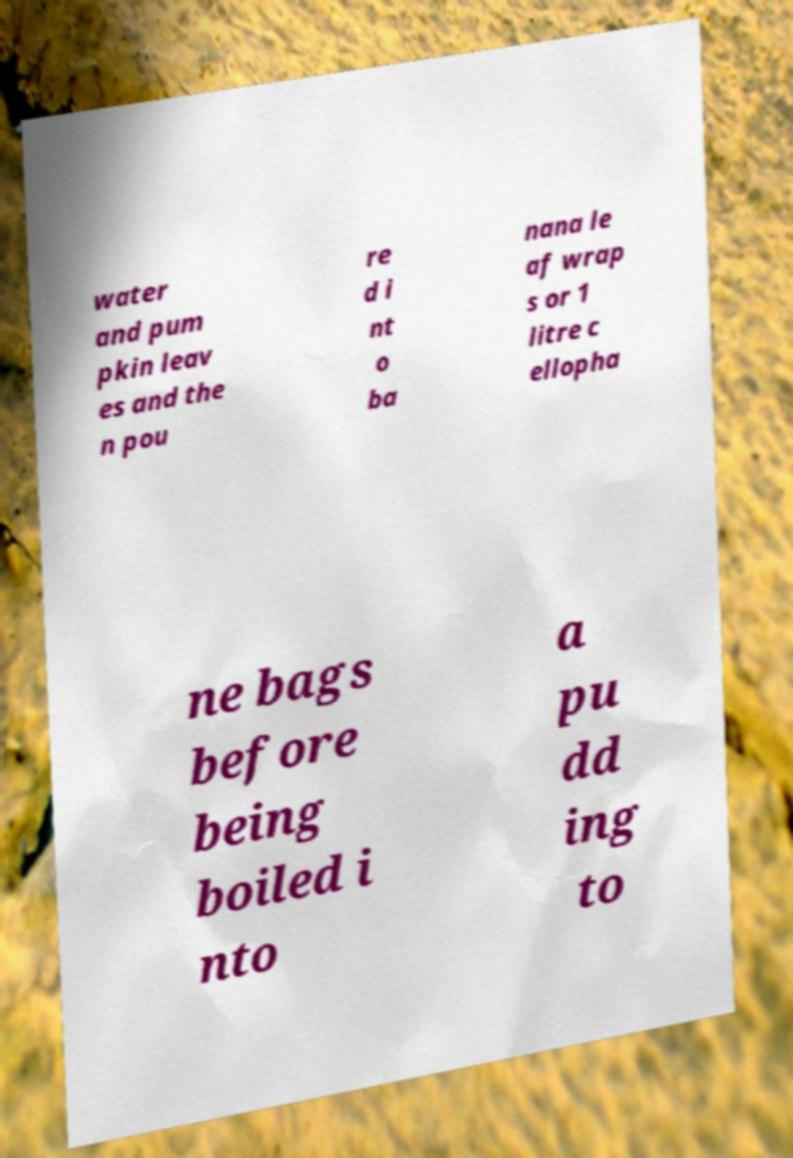Can you accurately transcribe the text from the provided image for me? water and pum pkin leav es and the n pou re d i nt o ba nana le af wrap s or 1 litre c ellopha ne bags before being boiled i nto a pu dd ing to 